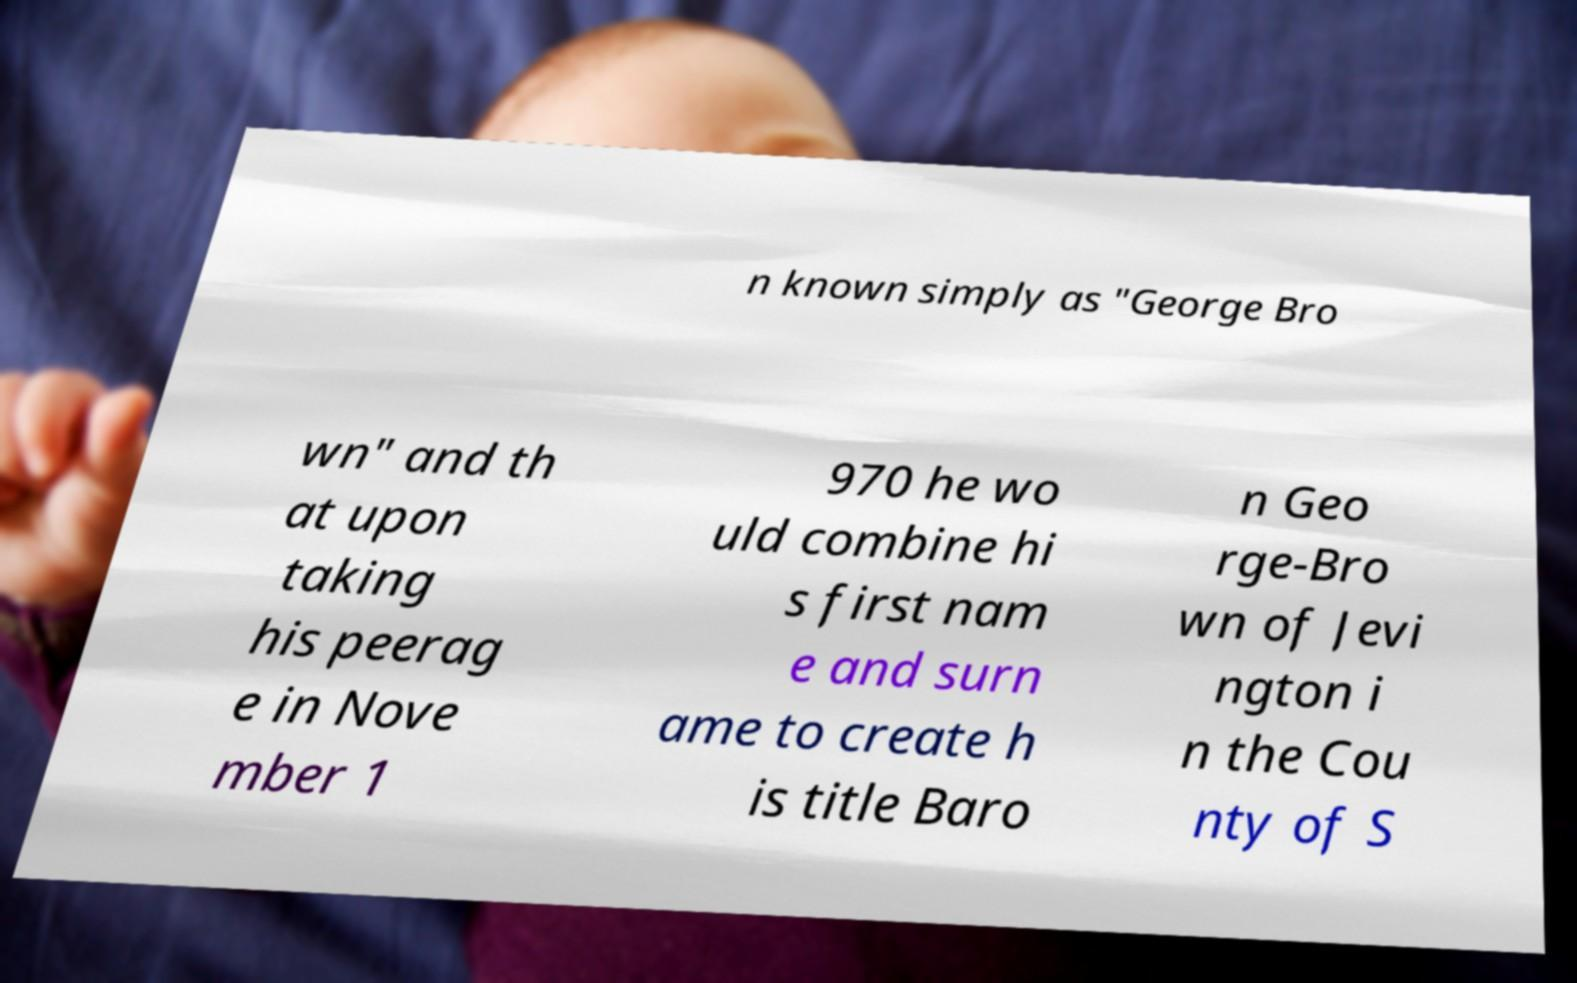I need the written content from this picture converted into text. Can you do that? n known simply as "George Bro wn" and th at upon taking his peerag e in Nove mber 1 970 he wo uld combine hi s first nam e and surn ame to create h is title Baro n Geo rge-Bro wn of Jevi ngton i n the Cou nty of S 